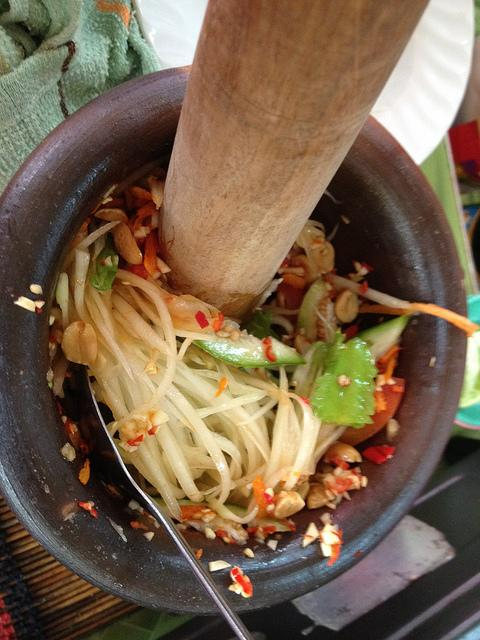What is the use of the pestle and mortar in the picture above? grinding 